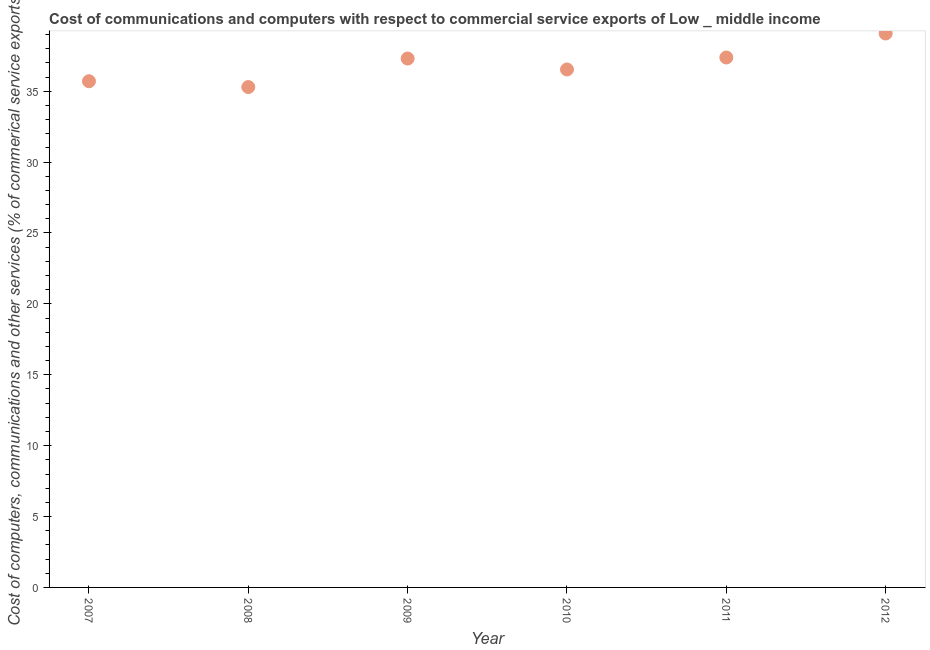What is the  computer and other services in 2009?
Give a very brief answer. 37.3. Across all years, what is the maximum  computer and other services?
Your answer should be very brief. 39.07. Across all years, what is the minimum cost of communications?
Offer a terse response. 35.29. In which year was the cost of communications maximum?
Make the answer very short. 2012. In which year was the  computer and other services minimum?
Offer a very short reply. 2008. What is the sum of the cost of communications?
Keep it short and to the point. 221.28. What is the difference between the cost of communications in 2007 and 2009?
Your answer should be compact. -1.6. What is the average  computer and other services per year?
Offer a terse response. 36.88. What is the median cost of communications?
Your response must be concise. 36.92. Do a majority of the years between 2007 and 2010 (inclusive) have cost of communications greater than 38 %?
Provide a succinct answer. No. What is the ratio of the  computer and other services in 2008 to that in 2010?
Ensure brevity in your answer.  0.97. What is the difference between the highest and the second highest  computer and other services?
Keep it short and to the point. 1.69. What is the difference between the highest and the lowest cost of communications?
Ensure brevity in your answer.  3.78. In how many years, is the  computer and other services greater than the average  computer and other services taken over all years?
Your response must be concise. 3. Does the cost of communications monotonically increase over the years?
Offer a very short reply. No. How many dotlines are there?
Your answer should be compact. 1. Does the graph contain any zero values?
Keep it short and to the point. No. What is the title of the graph?
Your answer should be very brief. Cost of communications and computers with respect to commercial service exports of Low _ middle income. What is the label or title of the X-axis?
Your answer should be very brief. Year. What is the label or title of the Y-axis?
Ensure brevity in your answer.  Cost of computers, communications and other services (% of commerical service exports). What is the Cost of computers, communications and other services (% of commerical service exports) in 2007?
Your answer should be compact. 35.7. What is the Cost of computers, communications and other services (% of commerical service exports) in 2008?
Give a very brief answer. 35.29. What is the Cost of computers, communications and other services (% of commerical service exports) in 2009?
Your answer should be very brief. 37.3. What is the Cost of computers, communications and other services (% of commerical service exports) in 2010?
Keep it short and to the point. 36.53. What is the Cost of computers, communications and other services (% of commerical service exports) in 2011?
Offer a terse response. 37.38. What is the Cost of computers, communications and other services (% of commerical service exports) in 2012?
Your answer should be compact. 39.07. What is the difference between the Cost of computers, communications and other services (% of commerical service exports) in 2007 and 2008?
Ensure brevity in your answer.  0.41. What is the difference between the Cost of computers, communications and other services (% of commerical service exports) in 2007 and 2009?
Your answer should be compact. -1.6. What is the difference between the Cost of computers, communications and other services (% of commerical service exports) in 2007 and 2010?
Provide a short and direct response. -0.83. What is the difference between the Cost of computers, communications and other services (% of commerical service exports) in 2007 and 2011?
Offer a very short reply. -1.67. What is the difference between the Cost of computers, communications and other services (% of commerical service exports) in 2007 and 2012?
Your answer should be very brief. -3.37. What is the difference between the Cost of computers, communications and other services (% of commerical service exports) in 2008 and 2009?
Ensure brevity in your answer.  -2.01. What is the difference between the Cost of computers, communications and other services (% of commerical service exports) in 2008 and 2010?
Your answer should be compact. -1.24. What is the difference between the Cost of computers, communications and other services (% of commerical service exports) in 2008 and 2011?
Provide a succinct answer. -2.09. What is the difference between the Cost of computers, communications and other services (% of commerical service exports) in 2008 and 2012?
Make the answer very short. -3.78. What is the difference between the Cost of computers, communications and other services (% of commerical service exports) in 2009 and 2010?
Ensure brevity in your answer.  0.77. What is the difference between the Cost of computers, communications and other services (% of commerical service exports) in 2009 and 2011?
Make the answer very short. -0.07. What is the difference between the Cost of computers, communications and other services (% of commerical service exports) in 2009 and 2012?
Make the answer very short. -1.77. What is the difference between the Cost of computers, communications and other services (% of commerical service exports) in 2010 and 2011?
Provide a short and direct response. -0.85. What is the difference between the Cost of computers, communications and other services (% of commerical service exports) in 2010 and 2012?
Ensure brevity in your answer.  -2.54. What is the difference between the Cost of computers, communications and other services (% of commerical service exports) in 2011 and 2012?
Give a very brief answer. -1.69. What is the ratio of the Cost of computers, communications and other services (% of commerical service exports) in 2007 to that in 2008?
Your answer should be very brief. 1.01. What is the ratio of the Cost of computers, communications and other services (% of commerical service exports) in 2007 to that in 2009?
Your answer should be very brief. 0.96. What is the ratio of the Cost of computers, communications and other services (% of commerical service exports) in 2007 to that in 2011?
Provide a succinct answer. 0.95. What is the ratio of the Cost of computers, communications and other services (% of commerical service exports) in 2007 to that in 2012?
Give a very brief answer. 0.91. What is the ratio of the Cost of computers, communications and other services (% of commerical service exports) in 2008 to that in 2009?
Give a very brief answer. 0.95. What is the ratio of the Cost of computers, communications and other services (% of commerical service exports) in 2008 to that in 2011?
Give a very brief answer. 0.94. What is the ratio of the Cost of computers, communications and other services (% of commerical service exports) in 2008 to that in 2012?
Give a very brief answer. 0.9. What is the ratio of the Cost of computers, communications and other services (% of commerical service exports) in 2009 to that in 2010?
Make the answer very short. 1.02. What is the ratio of the Cost of computers, communications and other services (% of commerical service exports) in 2009 to that in 2012?
Your answer should be very brief. 0.95. What is the ratio of the Cost of computers, communications and other services (% of commerical service exports) in 2010 to that in 2011?
Offer a very short reply. 0.98. What is the ratio of the Cost of computers, communications and other services (% of commerical service exports) in 2010 to that in 2012?
Your answer should be compact. 0.94. 